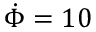<formula> <loc_0><loc_0><loc_500><loc_500>\dot { \Phi } = 1 0</formula> 